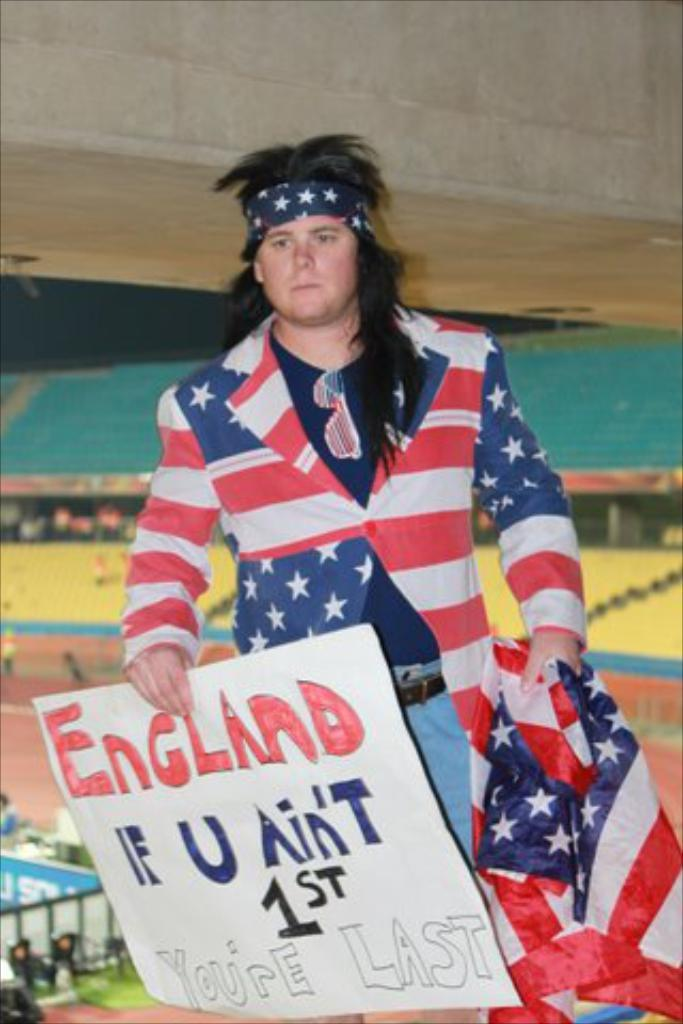<image>
Share a concise interpretation of the image provided. A man wearing a United States flag jacket holds a sign that says "England: If U Ain't 1st You're Last." 